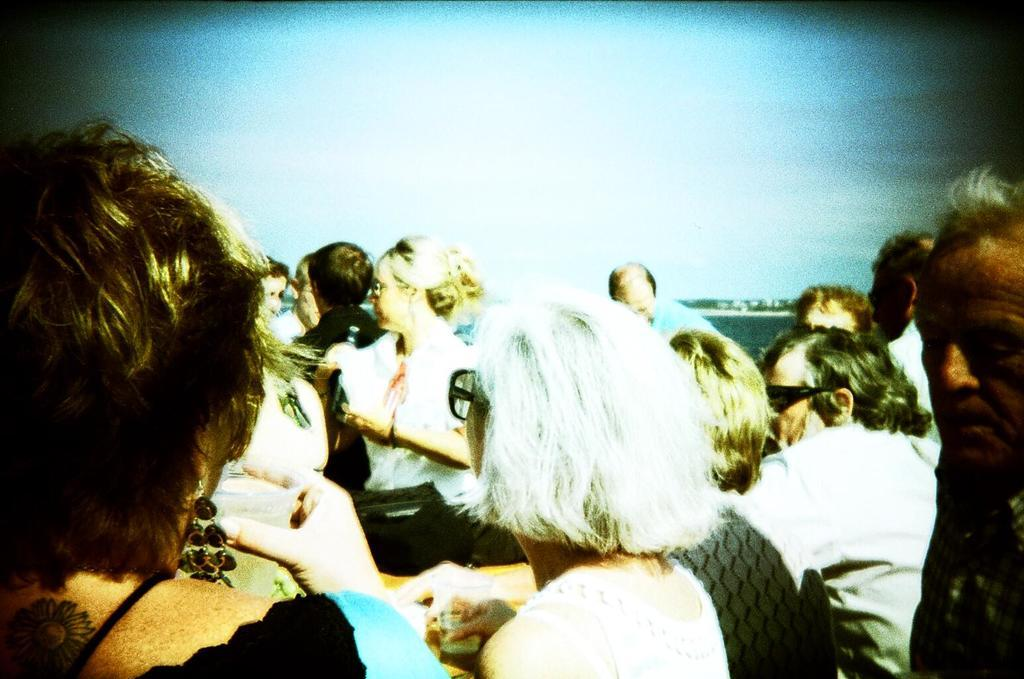How many people are in the image? There are persons in the image, but the exact number cannot be determined from the provided facts. What is visible in the background of the image? There is water and clouds in the sky visible in the background of the image. What type of orange can be seen being folded by a rake in the image? There is no orange or rake present in the image. 